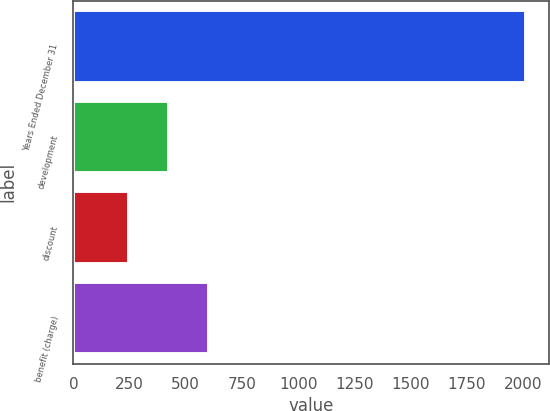Convert chart. <chart><loc_0><loc_0><loc_500><loc_500><bar_chart><fcel>Years Ended December 31<fcel>development<fcel>discount<fcel>benefit (charge)<nl><fcel>2013<fcel>424.5<fcel>248<fcel>601<nl></chart> 